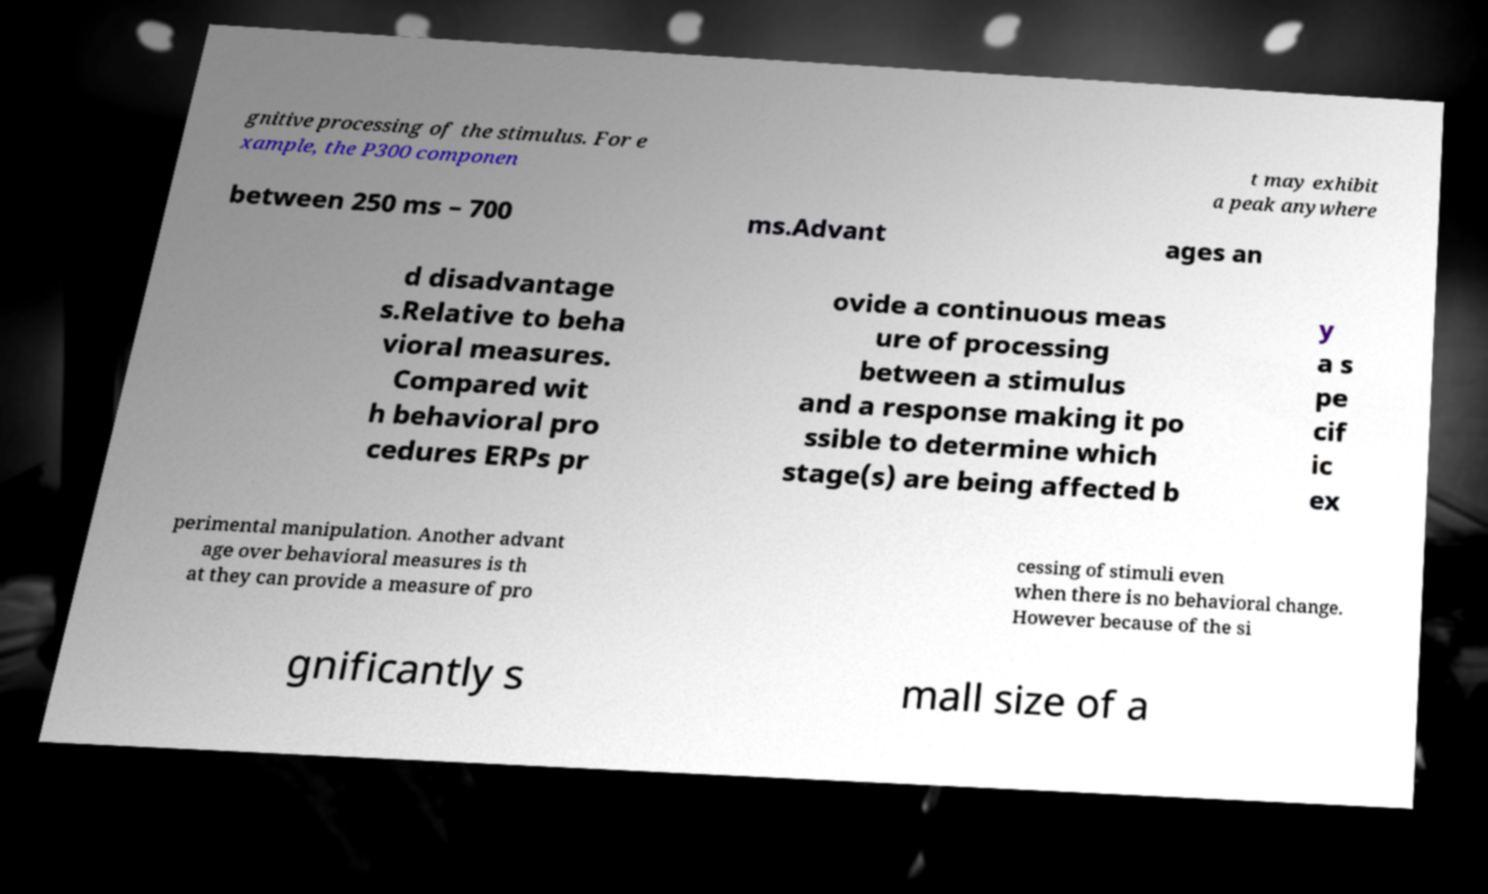Could you assist in decoding the text presented in this image and type it out clearly? gnitive processing of the stimulus. For e xample, the P300 componen t may exhibit a peak anywhere between 250 ms – 700 ms.Advant ages an d disadvantage s.Relative to beha vioral measures. Compared wit h behavioral pro cedures ERPs pr ovide a continuous meas ure of processing between a stimulus and a response making it po ssible to determine which stage(s) are being affected b y a s pe cif ic ex perimental manipulation. Another advant age over behavioral measures is th at they can provide a measure of pro cessing of stimuli even when there is no behavioral change. However because of the si gnificantly s mall size of a 